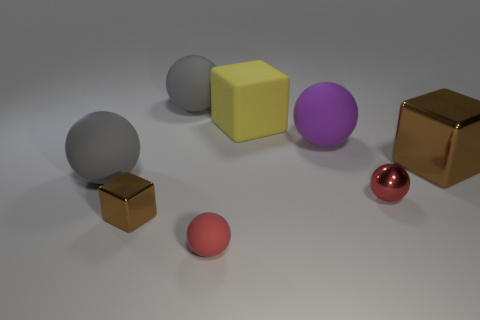Subtract all gray spheres. How many brown blocks are left? 2 Subtract all metal balls. How many balls are left? 4 Add 1 big gray rubber cubes. How many objects exist? 9 Subtract 1 blocks. How many blocks are left? 2 Subtract all yellow cubes. How many cubes are left? 2 Subtract all balls. How many objects are left? 3 Subtract all rubber balls. Subtract all tiny metallic balls. How many objects are left? 3 Add 4 small matte objects. How many small matte objects are left? 5 Add 1 small red balls. How many small red balls exist? 3 Subtract 0 brown balls. How many objects are left? 8 